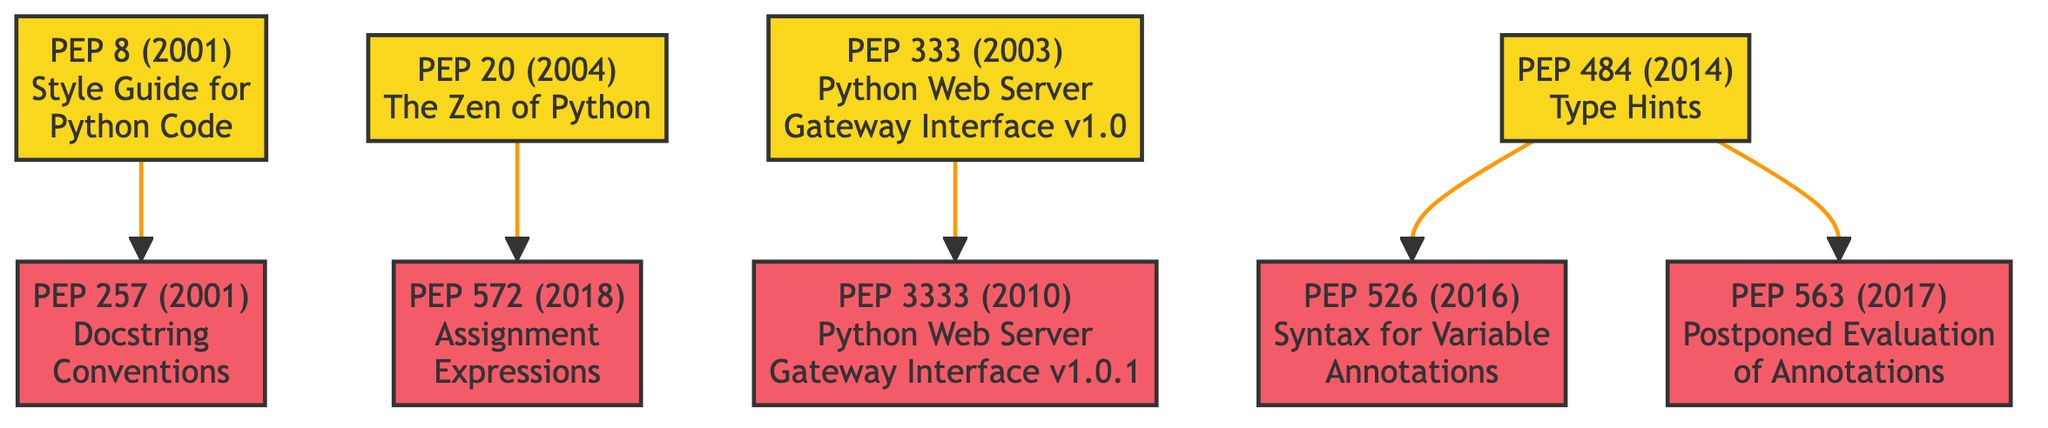What is the title of PEP 8? PEP 8 is labeled "Style Guide for Python Code" in the diagram, thus directly answering the question regarding its title.
Answer: Style Guide for Python Code How many children does PEP 484 have? By examining the diagram, it is clear that PEP 484 has two direct connections to its child nodes, which are PEP 526 and PEP 563, indicating it has two children.
Answer: 2 What year was PEP 20 introduced? The diagram includes the year associated with each PEP, and PEP 20 is listed with the year 2004, which answers the question about its introduction year.
Answer: 2004 Which PEP is a child of PEP 333? The diagram shows that PEP 333 has one child, which is PEP 3333, thus directly indicating PEP 333 as the parent of PEP 3333.
Answer: PEP 3333 What is the most recent PEP mentioned in the diagram? Upon reviewing the years associated with each PEP, the latest year is 2018, which corresponds to PEP 572, making it the most recent PEP listed in the diagram.
Answer: PEP 572 What are the important details associated with PEP 484? Analyzing the important details provided in the diagram, PEP 484's details include "Introduces a standard way to provide type hints" and "Enhances code readability and linting tools."
Answer: Introduces a standard way to provide type hints; Enhances code readability and linting tools Which relationship can be observed between PEP 8 and PEP 257? The diagram indicates a direct link from PEP 8 to PEP 257, confirming that PEP 257 is a child of PEP 8, establishing their parent-child relationship.
Answer: PEP 257 is a child of PEP 8 How many total PEPs are depicted in the diagram? By counting all the distinct PEPs listed in the diagram, including both parents and children, the total number comes to eight separate PEPs featured in the family tree structure.
Answer: 8 What is the title of the PEP with ID 563? The diagram specifies the title associated with PEP ID 563 as "Postponed Evaluation of Annotations," thus providing a direct answer to the inquiry about this specific PEP.
Answer: Postponed Evaluation of Annotations 